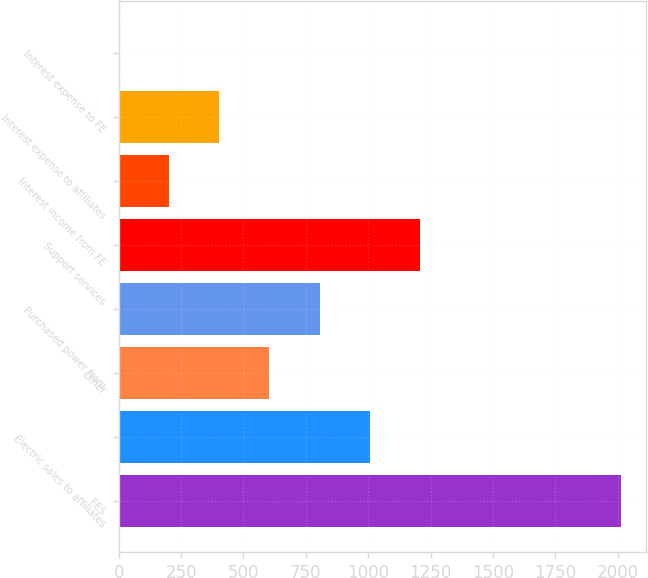Convert chart. <chart><loc_0><loc_0><loc_500><loc_500><bar_chart><fcel>FES<fcel>Electric sales to affiliates<fcel>Other<fcel>Purchased power from<fcel>Support services<fcel>Interest income from FE<fcel>Interest expense to affiliates<fcel>Interest expense to FE<nl><fcel>2012<fcel>1006.5<fcel>604.3<fcel>805.4<fcel>1207.6<fcel>202.1<fcel>403.2<fcel>1<nl></chart> 